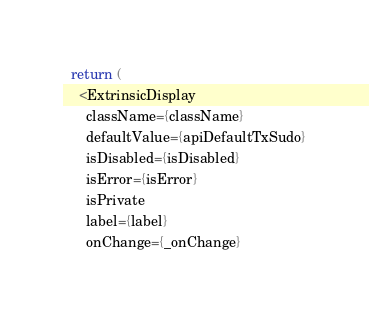Convert code to text. <code><loc_0><loc_0><loc_500><loc_500><_TypeScript_>  return (
    <ExtrinsicDisplay
      className={className}
      defaultValue={apiDefaultTxSudo}
      isDisabled={isDisabled}
      isError={isError}
      isPrivate
      label={label}
      onChange={_onChange}</code> 